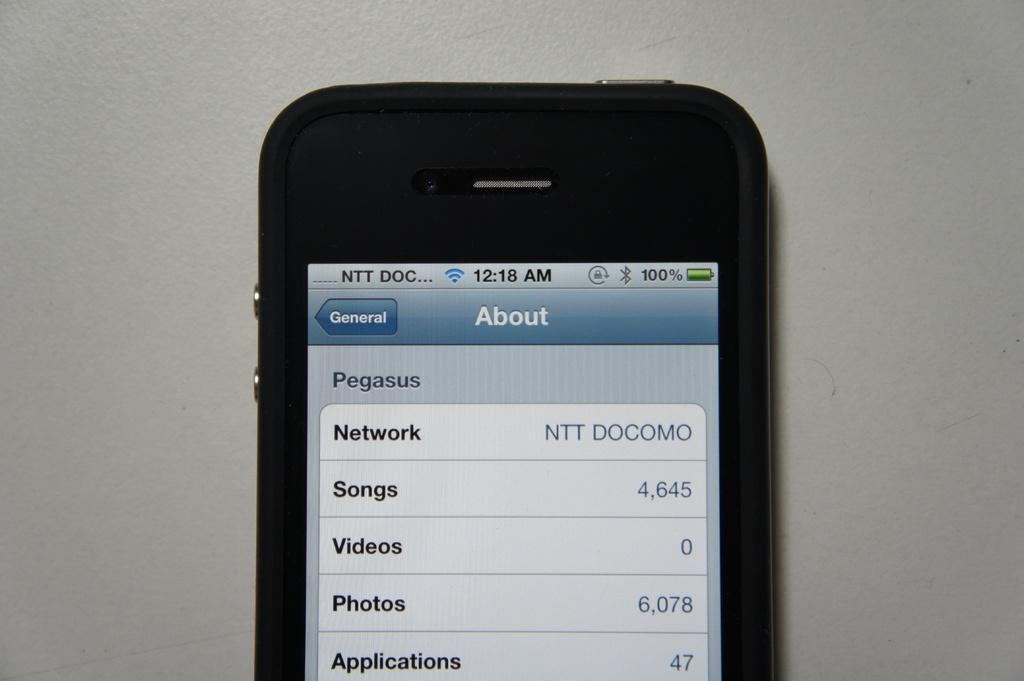Provide a one-sentence caption for the provided image. The phone has exactly 4645 different songs on it. 